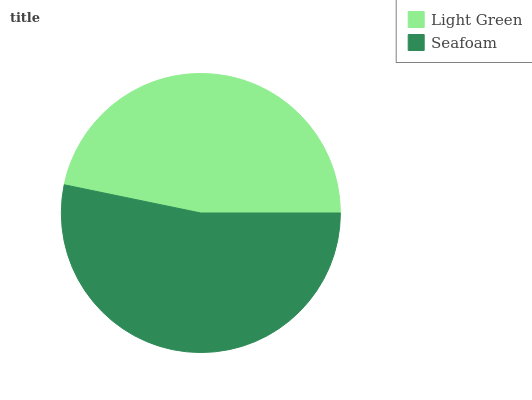Is Light Green the minimum?
Answer yes or no. Yes. Is Seafoam the maximum?
Answer yes or no. Yes. Is Seafoam the minimum?
Answer yes or no. No. Is Seafoam greater than Light Green?
Answer yes or no. Yes. Is Light Green less than Seafoam?
Answer yes or no. Yes. Is Light Green greater than Seafoam?
Answer yes or no. No. Is Seafoam less than Light Green?
Answer yes or no. No. Is Seafoam the high median?
Answer yes or no. Yes. Is Light Green the low median?
Answer yes or no. Yes. Is Light Green the high median?
Answer yes or no. No. Is Seafoam the low median?
Answer yes or no. No. 